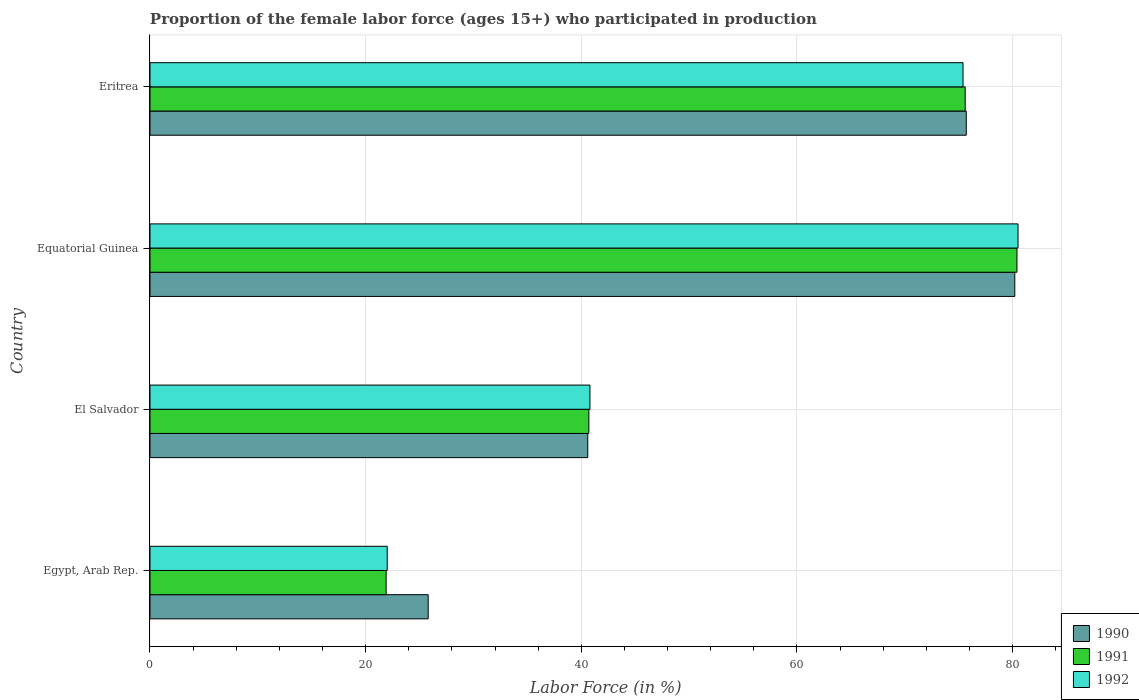How many different coloured bars are there?
Keep it short and to the point. 3. How many groups of bars are there?
Give a very brief answer. 4. Are the number of bars per tick equal to the number of legend labels?
Offer a terse response. Yes. How many bars are there on the 2nd tick from the top?
Ensure brevity in your answer.  3. What is the label of the 3rd group of bars from the top?
Your answer should be very brief. El Salvador. In how many cases, is the number of bars for a given country not equal to the number of legend labels?
Offer a very short reply. 0. What is the proportion of the female labor force who participated in production in 1992 in Equatorial Guinea?
Provide a short and direct response. 80.5. Across all countries, what is the maximum proportion of the female labor force who participated in production in 1990?
Your answer should be compact. 80.2. Across all countries, what is the minimum proportion of the female labor force who participated in production in 1991?
Provide a short and direct response. 21.9. In which country was the proportion of the female labor force who participated in production in 1992 maximum?
Make the answer very short. Equatorial Guinea. In which country was the proportion of the female labor force who participated in production in 1990 minimum?
Provide a short and direct response. Egypt, Arab Rep. What is the total proportion of the female labor force who participated in production in 1991 in the graph?
Offer a very short reply. 218.6. What is the difference between the proportion of the female labor force who participated in production in 1991 in El Salvador and that in Equatorial Guinea?
Your answer should be compact. -39.7. What is the difference between the proportion of the female labor force who participated in production in 1990 in Equatorial Guinea and the proportion of the female labor force who participated in production in 1991 in Egypt, Arab Rep.?
Provide a succinct answer. 58.3. What is the average proportion of the female labor force who participated in production in 1990 per country?
Provide a short and direct response. 55.57. What is the difference between the proportion of the female labor force who participated in production in 1992 and proportion of the female labor force who participated in production in 1991 in Eritrea?
Offer a terse response. -0.2. In how many countries, is the proportion of the female labor force who participated in production in 1991 greater than 40 %?
Provide a succinct answer. 3. What is the ratio of the proportion of the female labor force who participated in production in 1991 in El Salvador to that in Equatorial Guinea?
Ensure brevity in your answer.  0.51. Is the proportion of the female labor force who participated in production in 1992 in Egypt, Arab Rep. less than that in Eritrea?
Provide a succinct answer. Yes. Is the difference between the proportion of the female labor force who participated in production in 1992 in El Salvador and Equatorial Guinea greater than the difference between the proportion of the female labor force who participated in production in 1991 in El Salvador and Equatorial Guinea?
Make the answer very short. No. What is the difference between the highest and the lowest proportion of the female labor force who participated in production in 1992?
Give a very brief answer. 58.5. In how many countries, is the proportion of the female labor force who participated in production in 1990 greater than the average proportion of the female labor force who participated in production in 1990 taken over all countries?
Your answer should be very brief. 2. What does the 2nd bar from the top in Equatorial Guinea represents?
Offer a terse response. 1991. What does the 1st bar from the bottom in Equatorial Guinea represents?
Make the answer very short. 1990. Is it the case that in every country, the sum of the proportion of the female labor force who participated in production in 1991 and proportion of the female labor force who participated in production in 1990 is greater than the proportion of the female labor force who participated in production in 1992?
Ensure brevity in your answer.  Yes. How many bars are there?
Keep it short and to the point. 12. Are all the bars in the graph horizontal?
Offer a very short reply. Yes. What is the difference between two consecutive major ticks on the X-axis?
Offer a terse response. 20. Are the values on the major ticks of X-axis written in scientific E-notation?
Offer a terse response. No. Does the graph contain any zero values?
Offer a very short reply. No. Does the graph contain grids?
Offer a terse response. Yes. How many legend labels are there?
Offer a very short reply. 3. What is the title of the graph?
Your response must be concise. Proportion of the female labor force (ages 15+) who participated in production. Does "2015" appear as one of the legend labels in the graph?
Your response must be concise. No. What is the label or title of the Y-axis?
Make the answer very short. Country. What is the Labor Force (in %) in 1990 in Egypt, Arab Rep.?
Offer a very short reply. 25.8. What is the Labor Force (in %) of 1991 in Egypt, Arab Rep.?
Provide a short and direct response. 21.9. What is the Labor Force (in %) in 1990 in El Salvador?
Your answer should be compact. 40.6. What is the Labor Force (in %) in 1991 in El Salvador?
Your answer should be very brief. 40.7. What is the Labor Force (in %) in 1992 in El Salvador?
Keep it short and to the point. 40.8. What is the Labor Force (in %) in 1990 in Equatorial Guinea?
Your answer should be compact. 80.2. What is the Labor Force (in %) in 1991 in Equatorial Guinea?
Your answer should be compact. 80.4. What is the Labor Force (in %) in 1992 in Equatorial Guinea?
Offer a very short reply. 80.5. What is the Labor Force (in %) in 1990 in Eritrea?
Ensure brevity in your answer.  75.7. What is the Labor Force (in %) of 1991 in Eritrea?
Your response must be concise. 75.6. What is the Labor Force (in %) in 1992 in Eritrea?
Make the answer very short. 75.4. Across all countries, what is the maximum Labor Force (in %) in 1990?
Make the answer very short. 80.2. Across all countries, what is the maximum Labor Force (in %) in 1991?
Provide a short and direct response. 80.4. Across all countries, what is the maximum Labor Force (in %) of 1992?
Provide a short and direct response. 80.5. Across all countries, what is the minimum Labor Force (in %) in 1990?
Provide a succinct answer. 25.8. Across all countries, what is the minimum Labor Force (in %) in 1991?
Your answer should be compact. 21.9. What is the total Labor Force (in %) of 1990 in the graph?
Offer a terse response. 222.3. What is the total Labor Force (in %) of 1991 in the graph?
Provide a short and direct response. 218.6. What is the total Labor Force (in %) of 1992 in the graph?
Your response must be concise. 218.7. What is the difference between the Labor Force (in %) of 1990 in Egypt, Arab Rep. and that in El Salvador?
Your answer should be compact. -14.8. What is the difference between the Labor Force (in %) in 1991 in Egypt, Arab Rep. and that in El Salvador?
Provide a succinct answer. -18.8. What is the difference between the Labor Force (in %) of 1992 in Egypt, Arab Rep. and that in El Salvador?
Your answer should be very brief. -18.8. What is the difference between the Labor Force (in %) in 1990 in Egypt, Arab Rep. and that in Equatorial Guinea?
Provide a short and direct response. -54.4. What is the difference between the Labor Force (in %) in 1991 in Egypt, Arab Rep. and that in Equatorial Guinea?
Ensure brevity in your answer.  -58.5. What is the difference between the Labor Force (in %) of 1992 in Egypt, Arab Rep. and that in Equatorial Guinea?
Ensure brevity in your answer.  -58.5. What is the difference between the Labor Force (in %) in 1990 in Egypt, Arab Rep. and that in Eritrea?
Provide a succinct answer. -49.9. What is the difference between the Labor Force (in %) of 1991 in Egypt, Arab Rep. and that in Eritrea?
Ensure brevity in your answer.  -53.7. What is the difference between the Labor Force (in %) in 1992 in Egypt, Arab Rep. and that in Eritrea?
Provide a short and direct response. -53.4. What is the difference between the Labor Force (in %) of 1990 in El Salvador and that in Equatorial Guinea?
Make the answer very short. -39.6. What is the difference between the Labor Force (in %) of 1991 in El Salvador and that in Equatorial Guinea?
Your answer should be compact. -39.7. What is the difference between the Labor Force (in %) of 1992 in El Salvador and that in Equatorial Guinea?
Give a very brief answer. -39.7. What is the difference between the Labor Force (in %) of 1990 in El Salvador and that in Eritrea?
Your answer should be very brief. -35.1. What is the difference between the Labor Force (in %) in 1991 in El Salvador and that in Eritrea?
Provide a short and direct response. -34.9. What is the difference between the Labor Force (in %) in 1992 in El Salvador and that in Eritrea?
Ensure brevity in your answer.  -34.6. What is the difference between the Labor Force (in %) in 1992 in Equatorial Guinea and that in Eritrea?
Offer a very short reply. 5.1. What is the difference between the Labor Force (in %) of 1990 in Egypt, Arab Rep. and the Labor Force (in %) of 1991 in El Salvador?
Make the answer very short. -14.9. What is the difference between the Labor Force (in %) of 1990 in Egypt, Arab Rep. and the Labor Force (in %) of 1992 in El Salvador?
Ensure brevity in your answer.  -15. What is the difference between the Labor Force (in %) of 1991 in Egypt, Arab Rep. and the Labor Force (in %) of 1992 in El Salvador?
Offer a very short reply. -18.9. What is the difference between the Labor Force (in %) of 1990 in Egypt, Arab Rep. and the Labor Force (in %) of 1991 in Equatorial Guinea?
Your response must be concise. -54.6. What is the difference between the Labor Force (in %) of 1990 in Egypt, Arab Rep. and the Labor Force (in %) of 1992 in Equatorial Guinea?
Give a very brief answer. -54.7. What is the difference between the Labor Force (in %) of 1991 in Egypt, Arab Rep. and the Labor Force (in %) of 1992 in Equatorial Guinea?
Offer a very short reply. -58.6. What is the difference between the Labor Force (in %) of 1990 in Egypt, Arab Rep. and the Labor Force (in %) of 1991 in Eritrea?
Make the answer very short. -49.8. What is the difference between the Labor Force (in %) in 1990 in Egypt, Arab Rep. and the Labor Force (in %) in 1992 in Eritrea?
Make the answer very short. -49.6. What is the difference between the Labor Force (in %) in 1991 in Egypt, Arab Rep. and the Labor Force (in %) in 1992 in Eritrea?
Offer a terse response. -53.5. What is the difference between the Labor Force (in %) of 1990 in El Salvador and the Labor Force (in %) of 1991 in Equatorial Guinea?
Your response must be concise. -39.8. What is the difference between the Labor Force (in %) in 1990 in El Salvador and the Labor Force (in %) in 1992 in Equatorial Guinea?
Your answer should be compact. -39.9. What is the difference between the Labor Force (in %) in 1991 in El Salvador and the Labor Force (in %) in 1992 in Equatorial Guinea?
Offer a very short reply. -39.8. What is the difference between the Labor Force (in %) of 1990 in El Salvador and the Labor Force (in %) of 1991 in Eritrea?
Make the answer very short. -35. What is the difference between the Labor Force (in %) in 1990 in El Salvador and the Labor Force (in %) in 1992 in Eritrea?
Give a very brief answer. -34.8. What is the difference between the Labor Force (in %) of 1991 in El Salvador and the Labor Force (in %) of 1992 in Eritrea?
Make the answer very short. -34.7. What is the difference between the Labor Force (in %) in 1990 in Equatorial Guinea and the Labor Force (in %) in 1992 in Eritrea?
Give a very brief answer. 4.8. What is the average Labor Force (in %) of 1990 per country?
Provide a succinct answer. 55.58. What is the average Labor Force (in %) in 1991 per country?
Give a very brief answer. 54.65. What is the average Labor Force (in %) in 1992 per country?
Keep it short and to the point. 54.67. What is the difference between the Labor Force (in %) in 1990 and Labor Force (in %) in 1991 in Egypt, Arab Rep.?
Your response must be concise. 3.9. What is the difference between the Labor Force (in %) in 1990 and Labor Force (in %) in 1992 in Egypt, Arab Rep.?
Keep it short and to the point. 3.8. What is the difference between the Labor Force (in %) of 1990 and Labor Force (in %) of 1991 in Equatorial Guinea?
Ensure brevity in your answer.  -0.2. What is the difference between the Labor Force (in %) of 1990 and Labor Force (in %) of 1992 in Equatorial Guinea?
Offer a very short reply. -0.3. What is the difference between the Labor Force (in %) of 1991 and Labor Force (in %) of 1992 in Eritrea?
Your response must be concise. 0.2. What is the ratio of the Labor Force (in %) in 1990 in Egypt, Arab Rep. to that in El Salvador?
Your answer should be compact. 0.64. What is the ratio of the Labor Force (in %) in 1991 in Egypt, Arab Rep. to that in El Salvador?
Keep it short and to the point. 0.54. What is the ratio of the Labor Force (in %) in 1992 in Egypt, Arab Rep. to that in El Salvador?
Make the answer very short. 0.54. What is the ratio of the Labor Force (in %) in 1990 in Egypt, Arab Rep. to that in Equatorial Guinea?
Make the answer very short. 0.32. What is the ratio of the Labor Force (in %) of 1991 in Egypt, Arab Rep. to that in Equatorial Guinea?
Provide a succinct answer. 0.27. What is the ratio of the Labor Force (in %) in 1992 in Egypt, Arab Rep. to that in Equatorial Guinea?
Ensure brevity in your answer.  0.27. What is the ratio of the Labor Force (in %) in 1990 in Egypt, Arab Rep. to that in Eritrea?
Make the answer very short. 0.34. What is the ratio of the Labor Force (in %) in 1991 in Egypt, Arab Rep. to that in Eritrea?
Your answer should be very brief. 0.29. What is the ratio of the Labor Force (in %) of 1992 in Egypt, Arab Rep. to that in Eritrea?
Make the answer very short. 0.29. What is the ratio of the Labor Force (in %) of 1990 in El Salvador to that in Equatorial Guinea?
Your response must be concise. 0.51. What is the ratio of the Labor Force (in %) of 1991 in El Salvador to that in Equatorial Guinea?
Give a very brief answer. 0.51. What is the ratio of the Labor Force (in %) of 1992 in El Salvador to that in Equatorial Guinea?
Your answer should be compact. 0.51. What is the ratio of the Labor Force (in %) of 1990 in El Salvador to that in Eritrea?
Your answer should be compact. 0.54. What is the ratio of the Labor Force (in %) in 1991 in El Salvador to that in Eritrea?
Your answer should be very brief. 0.54. What is the ratio of the Labor Force (in %) in 1992 in El Salvador to that in Eritrea?
Ensure brevity in your answer.  0.54. What is the ratio of the Labor Force (in %) of 1990 in Equatorial Guinea to that in Eritrea?
Provide a succinct answer. 1.06. What is the ratio of the Labor Force (in %) of 1991 in Equatorial Guinea to that in Eritrea?
Ensure brevity in your answer.  1.06. What is the ratio of the Labor Force (in %) of 1992 in Equatorial Guinea to that in Eritrea?
Your response must be concise. 1.07. What is the difference between the highest and the lowest Labor Force (in %) in 1990?
Your response must be concise. 54.4. What is the difference between the highest and the lowest Labor Force (in %) in 1991?
Your answer should be very brief. 58.5. What is the difference between the highest and the lowest Labor Force (in %) of 1992?
Your answer should be very brief. 58.5. 